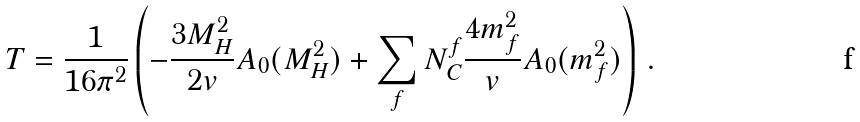Convert formula to latex. <formula><loc_0><loc_0><loc_500><loc_500>T = \frac { 1 } { 1 6 \pi ^ { 2 } } \left ( - \frac { 3 M _ { H } ^ { 2 } } { 2 v } A _ { 0 } ( M _ { H } ^ { 2 } ) + \sum _ { f } N _ { C } ^ { f } \frac { 4 m _ { f } ^ { 2 } } { v } A _ { 0 } ( m _ { f } ^ { 2 } ) \right ) \, .</formula> 